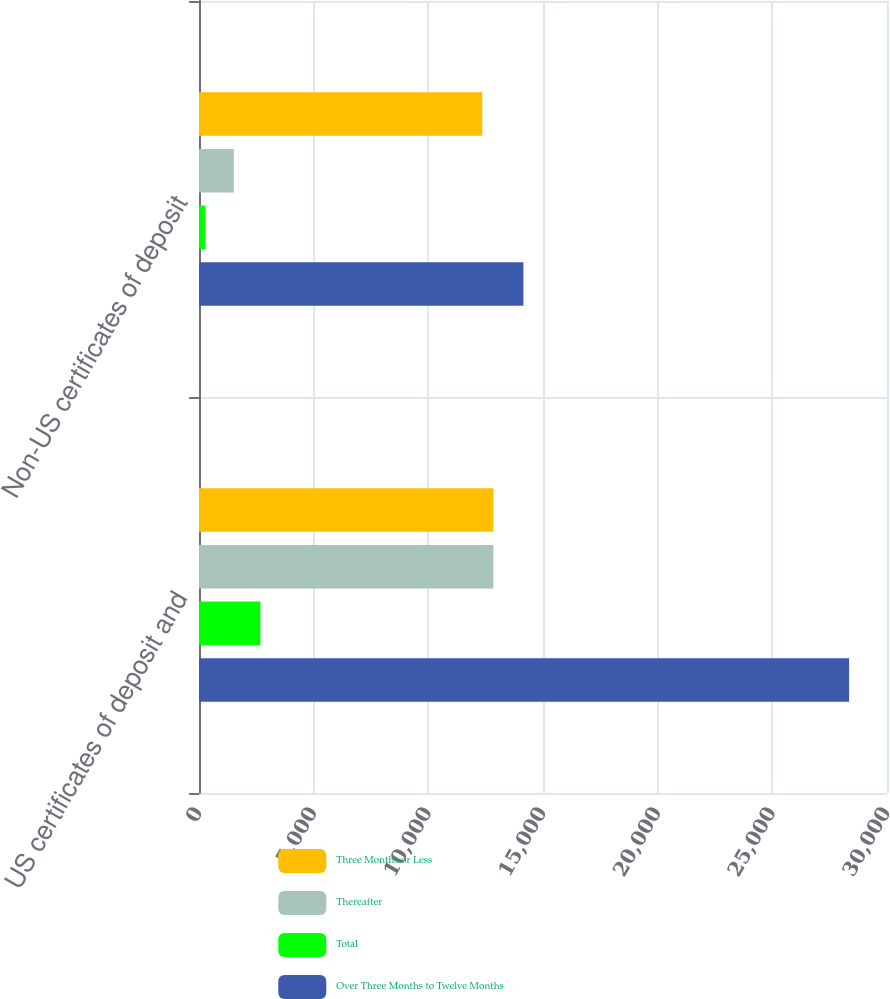<chart> <loc_0><loc_0><loc_500><loc_500><stacked_bar_chart><ecel><fcel>US certificates of deposit and<fcel>Non-US certificates of deposit<nl><fcel>Three Months or Less<fcel>12836<fcel>12352<nl><fcel>Thereafter<fcel>12834<fcel>1517<nl><fcel>Total<fcel>2677<fcel>277<nl><fcel>Over Three Months to Twelve Months<fcel>28347<fcel>14146<nl></chart> 